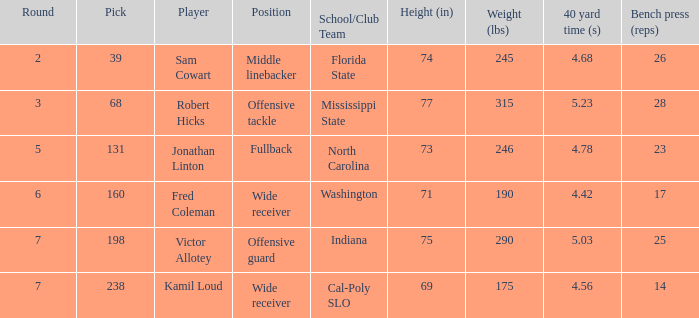Which School/Club Team has a Pick of 198? Indiana. 